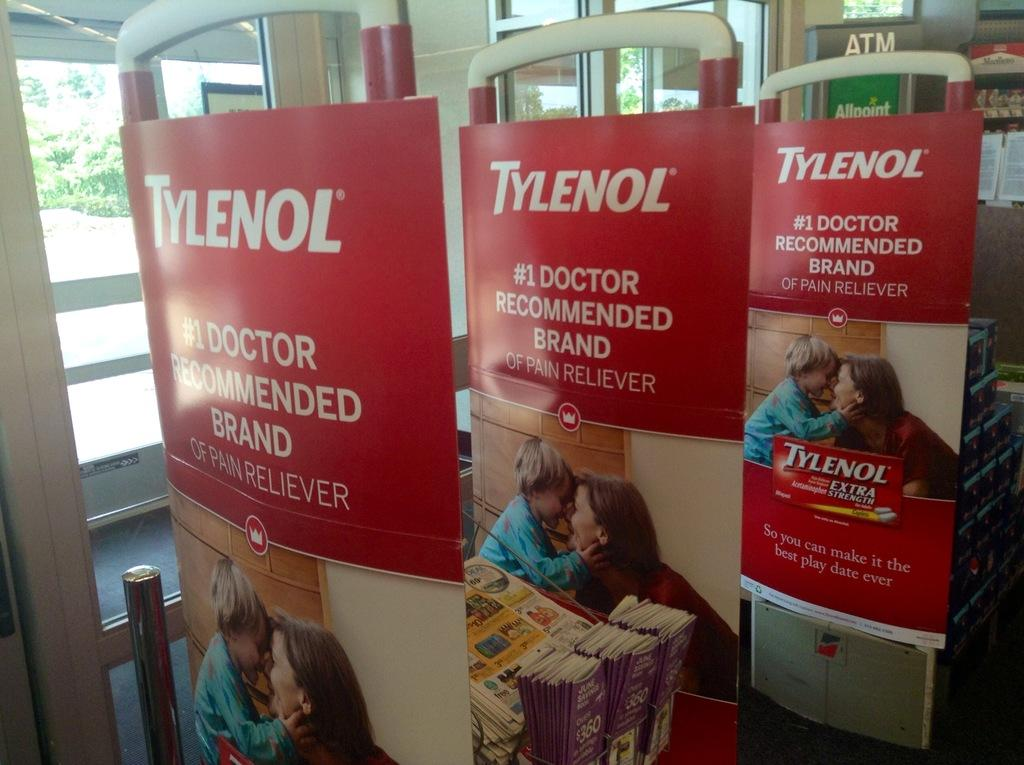<image>
Summarize the visual content of the image. tylenol extra strength displays at a store depecting a woman and child 